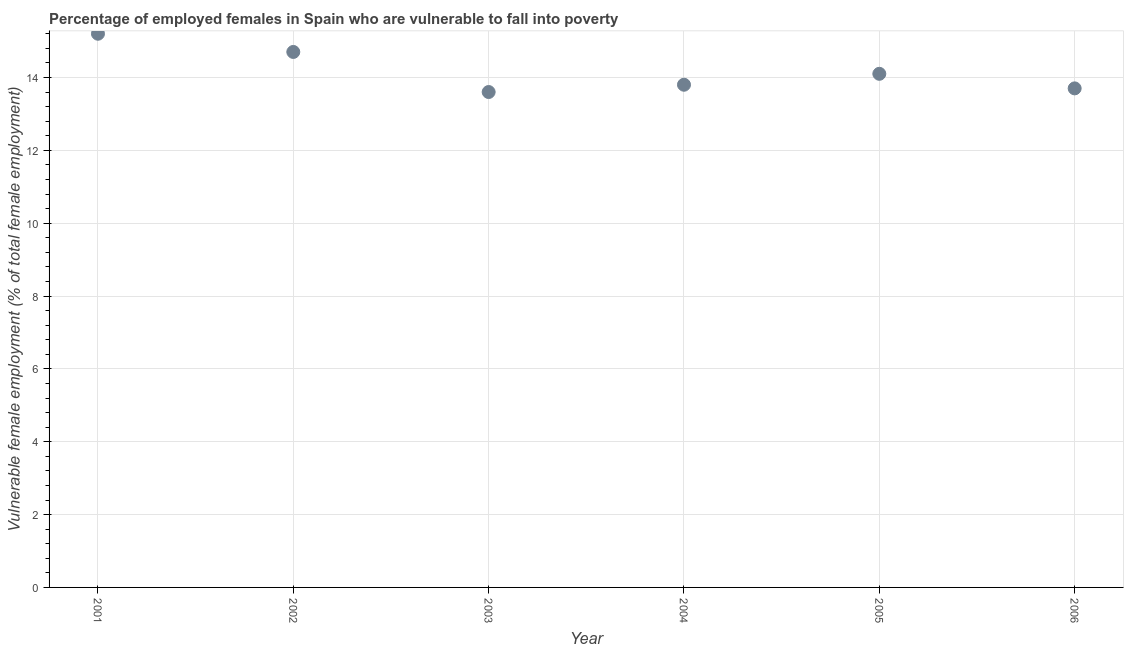What is the percentage of employed females who are vulnerable to fall into poverty in 2001?
Your response must be concise. 15.2. Across all years, what is the maximum percentage of employed females who are vulnerable to fall into poverty?
Ensure brevity in your answer.  15.2. Across all years, what is the minimum percentage of employed females who are vulnerable to fall into poverty?
Give a very brief answer. 13.6. In which year was the percentage of employed females who are vulnerable to fall into poverty minimum?
Your answer should be very brief. 2003. What is the sum of the percentage of employed females who are vulnerable to fall into poverty?
Offer a very short reply. 85.1. What is the difference between the percentage of employed females who are vulnerable to fall into poverty in 2004 and 2005?
Your response must be concise. -0.3. What is the average percentage of employed females who are vulnerable to fall into poverty per year?
Your answer should be compact. 14.18. What is the median percentage of employed females who are vulnerable to fall into poverty?
Your response must be concise. 13.95. In how many years, is the percentage of employed females who are vulnerable to fall into poverty greater than 10.8 %?
Provide a short and direct response. 6. What is the ratio of the percentage of employed females who are vulnerable to fall into poverty in 2004 to that in 2006?
Make the answer very short. 1.01. What is the difference between the highest and the lowest percentage of employed females who are vulnerable to fall into poverty?
Your response must be concise. 1.6. In how many years, is the percentage of employed females who are vulnerable to fall into poverty greater than the average percentage of employed females who are vulnerable to fall into poverty taken over all years?
Make the answer very short. 2. Does the percentage of employed females who are vulnerable to fall into poverty monotonically increase over the years?
Provide a short and direct response. No. How many dotlines are there?
Provide a short and direct response. 1. How many years are there in the graph?
Provide a short and direct response. 6. What is the difference between two consecutive major ticks on the Y-axis?
Give a very brief answer. 2. Does the graph contain any zero values?
Give a very brief answer. No. Does the graph contain grids?
Your answer should be very brief. Yes. What is the title of the graph?
Provide a succinct answer. Percentage of employed females in Spain who are vulnerable to fall into poverty. What is the label or title of the Y-axis?
Ensure brevity in your answer.  Vulnerable female employment (% of total female employment). What is the Vulnerable female employment (% of total female employment) in 2001?
Provide a succinct answer. 15.2. What is the Vulnerable female employment (% of total female employment) in 2002?
Ensure brevity in your answer.  14.7. What is the Vulnerable female employment (% of total female employment) in 2003?
Provide a short and direct response. 13.6. What is the Vulnerable female employment (% of total female employment) in 2004?
Make the answer very short. 13.8. What is the Vulnerable female employment (% of total female employment) in 2005?
Provide a short and direct response. 14.1. What is the Vulnerable female employment (% of total female employment) in 2006?
Offer a terse response. 13.7. What is the difference between the Vulnerable female employment (% of total female employment) in 2001 and 2004?
Offer a very short reply. 1.4. What is the difference between the Vulnerable female employment (% of total female employment) in 2001 and 2005?
Your response must be concise. 1.1. What is the difference between the Vulnerable female employment (% of total female employment) in 2001 and 2006?
Your answer should be compact. 1.5. What is the difference between the Vulnerable female employment (% of total female employment) in 2002 and 2004?
Your answer should be very brief. 0.9. What is the difference between the Vulnerable female employment (% of total female employment) in 2002 and 2006?
Your answer should be compact. 1. What is the difference between the Vulnerable female employment (% of total female employment) in 2003 and 2004?
Ensure brevity in your answer.  -0.2. What is the difference between the Vulnerable female employment (% of total female employment) in 2003 and 2005?
Your answer should be very brief. -0.5. What is the difference between the Vulnerable female employment (% of total female employment) in 2005 and 2006?
Make the answer very short. 0.4. What is the ratio of the Vulnerable female employment (% of total female employment) in 2001 to that in 2002?
Give a very brief answer. 1.03. What is the ratio of the Vulnerable female employment (% of total female employment) in 2001 to that in 2003?
Offer a very short reply. 1.12. What is the ratio of the Vulnerable female employment (% of total female employment) in 2001 to that in 2004?
Keep it short and to the point. 1.1. What is the ratio of the Vulnerable female employment (% of total female employment) in 2001 to that in 2005?
Offer a terse response. 1.08. What is the ratio of the Vulnerable female employment (% of total female employment) in 2001 to that in 2006?
Offer a very short reply. 1.11. What is the ratio of the Vulnerable female employment (% of total female employment) in 2002 to that in 2003?
Your answer should be compact. 1.08. What is the ratio of the Vulnerable female employment (% of total female employment) in 2002 to that in 2004?
Your response must be concise. 1.06. What is the ratio of the Vulnerable female employment (% of total female employment) in 2002 to that in 2005?
Offer a very short reply. 1.04. What is the ratio of the Vulnerable female employment (% of total female employment) in 2002 to that in 2006?
Provide a short and direct response. 1.07. What is the ratio of the Vulnerable female employment (% of total female employment) in 2003 to that in 2005?
Offer a very short reply. 0.96. What is the ratio of the Vulnerable female employment (% of total female employment) in 2003 to that in 2006?
Offer a terse response. 0.99. What is the ratio of the Vulnerable female employment (% of total female employment) in 2004 to that in 2005?
Offer a terse response. 0.98. What is the ratio of the Vulnerable female employment (% of total female employment) in 2005 to that in 2006?
Offer a very short reply. 1.03. 